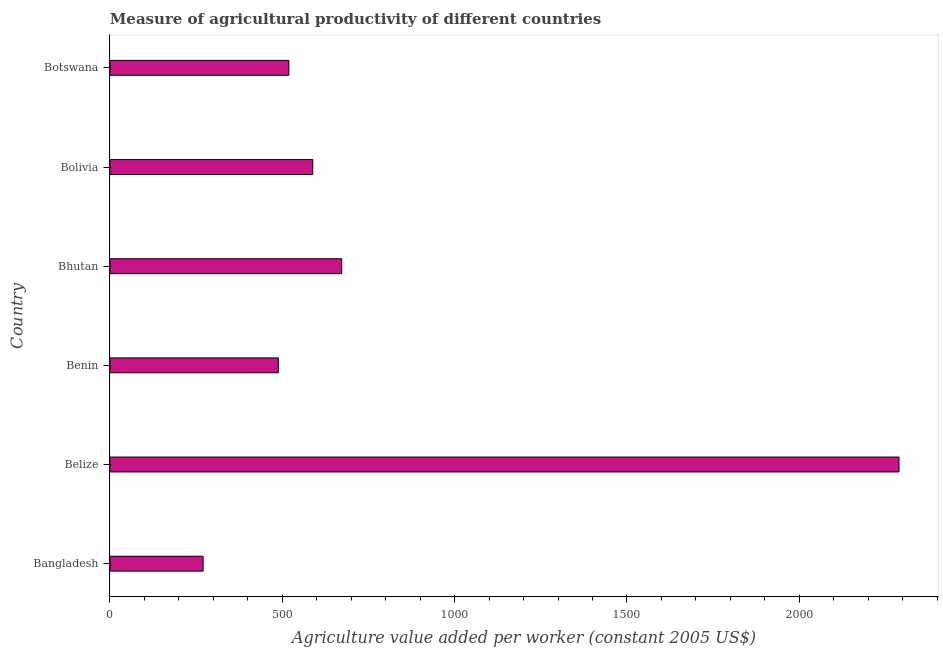What is the title of the graph?
Offer a very short reply. Measure of agricultural productivity of different countries. What is the label or title of the X-axis?
Keep it short and to the point. Agriculture value added per worker (constant 2005 US$). What is the label or title of the Y-axis?
Keep it short and to the point. Country. What is the agriculture value added per worker in Belize?
Give a very brief answer. 2289.18. Across all countries, what is the maximum agriculture value added per worker?
Offer a very short reply. 2289.18. Across all countries, what is the minimum agriculture value added per worker?
Ensure brevity in your answer.  270.45. In which country was the agriculture value added per worker maximum?
Make the answer very short. Belize. In which country was the agriculture value added per worker minimum?
Make the answer very short. Bangladesh. What is the sum of the agriculture value added per worker?
Provide a short and direct response. 4828.3. What is the difference between the agriculture value added per worker in Bolivia and Botswana?
Your answer should be very brief. 69.4. What is the average agriculture value added per worker per country?
Your response must be concise. 804.72. What is the median agriculture value added per worker?
Make the answer very short. 553.83. In how many countries, is the agriculture value added per worker greater than 1400 US$?
Your response must be concise. 1. What is the ratio of the agriculture value added per worker in Benin to that in Botswana?
Provide a short and direct response. 0.94. What is the difference between the highest and the second highest agriculture value added per worker?
Offer a very short reply. 1616.75. Is the sum of the agriculture value added per worker in Belize and Botswana greater than the maximum agriculture value added per worker across all countries?
Provide a short and direct response. Yes. What is the difference between the highest and the lowest agriculture value added per worker?
Your answer should be compact. 2018.73. How many bars are there?
Provide a short and direct response. 6. How many countries are there in the graph?
Give a very brief answer. 6. What is the difference between two consecutive major ticks on the X-axis?
Provide a short and direct response. 500. Are the values on the major ticks of X-axis written in scientific E-notation?
Provide a short and direct response. No. What is the Agriculture value added per worker (constant 2005 US$) of Bangladesh?
Keep it short and to the point. 270.45. What is the Agriculture value added per worker (constant 2005 US$) of Belize?
Offer a terse response. 2289.18. What is the Agriculture value added per worker (constant 2005 US$) of Benin?
Offer a very short reply. 488.58. What is the Agriculture value added per worker (constant 2005 US$) of Bhutan?
Your answer should be compact. 672.43. What is the Agriculture value added per worker (constant 2005 US$) of Bolivia?
Give a very brief answer. 588.54. What is the Agriculture value added per worker (constant 2005 US$) in Botswana?
Ensure brevity in your answer.  519.13. What is the difference between the Agriculture value added per worker (constant 2005 US$) in Bangladesh and Belize?
Your answer should be very brief. -2018.73. What is the difference between the Agriculture value added per worker (constant 2005 US$) in Bangladesh and Benin?
Offer a terse response. -218.12. What is the difference between the Agriculture value added per worker (constant 2005 US$) in Bangladesh and Bhutan?
Provide a succinct answer. -401.97. What is the difference between the Agriculture value added per worker (constant 2005 US$) in Bangladesh and Bolivia?
Keep it short and to the point. -318.08. What is the difference between the Agriculture value added per worker (constant 2005 US$) in Bangladesh and Botswana?
Your response must be concise. -248.68. What is the difference between the Agriculture value added per worker (constant 2005 US$) in Belize and Benin?
Provide a succinct answer. 1800.6. What is the difference between the Agriculture value added per worker (constant 2005 US$) in Belize and Bhutan?
Provide a succinct answer. 1616.75. What is the difference between the Agriculture value added per worker (constant 2005 US$) in Belize and Bolivia?
Give a very brief answer. 1700.64. What is the difference between the Agriculture value added per worker (constant 2005 US$) in Belize and Botswana?
Your response must be concise. 1770.04. What is the difference between the Agriculture value added per worker (constant 2005 US$) in Benin and Bhutan?
Ensure brevity in your answer.  -183.85. What is the difference between the Agriculture value added per worker (constant 2005 US$) in Benin and Bolivia?
Keep it short and to the point. -99.96. What is the difference between the Agriculture value added per worker (constant 2005 US$) in Benin and Botswana?
Offer a terse response. -30.56. What is the difference between the Agriculture value added per worker (constant 2005 US$) in Bhutan and Bolivia?
Offer a terse response. 83.89. What is the difference between the Agriculture value added per worker (constant 2005 US$) in Bhutan and Botswana?
Provide a short and direct response. 153.29. What is the difference between the Agriculture value added per worker (constant 2005 US$) in Bolivia and Botswana?
Offer a very short reply. 69.4. What is the ratio of the Agriculture value added per worker (constant 2005 US$) in Bangladesh to that in Belize?
Offer a terse response. 0.12. What is the ratio of the Agriculture value added per worker (constant 2005 US$) in Bangladesh to that in Benin?
Your response must be concise. 0.55. What is the ratio of the Agriculture value added per worker (constant 2005 US$) in Bangladesh to that in Bhutan?
Ensure brevity in your answer.  0.4. What is the ratio of the Agriculture value added per worker (constant 2005 US$) in Bangladesh to that in Bolivia?
Give a very brief answer. 0.46. What is the ratio of the Agriculture value added per worker (constant 2005 US$) in Bangladesh to that in Botswana?
Your response must be concise. 0.52. What is the ratio of the Agriculture value added per worker (constant 2005 US$) in Belize to that in Benin?
Give a very brief answer. 4.68. What is the ratio of the Agriculture value added per worker (constant 2005 US$) in Belize to that in Bhutan?
Your response must be concise. 3.4. What is the ratio of the Agriculture value added per worker (constant 2005 US$) in Belize to that in Bolivia?
Your answer should be very brief. 3.89. What is the ratio of the Agriculture value added per worker (constant 2005 US$) in Belize to that in Botswana?
Give a very brief answer. 4.41. What is the ratio of the Agriculture value added per worker (constant 2005 US$) in Benin to that in Bhutan?
Provide a succinct answer. 0.73. What is the ratio of the Agriculture value added per worker (constant 2005 US$) in Benin to that in Bolivia?
Ensure brevity in your answer.  0.83. What is the ratio of the Agriculture value added per worker (constant 2005 US$) in Benin to that in Botswana?
Offer a very short reply. 0.94. What is the ratio of the Agriculture value added per worker (constant 2005 US$) in Bhutan to that in Bolivia?
Offer a terse response. 1.14. What is the ratio of the Agriculture value added per worker (constant 2005 US$) in Bhutan to that in Botswana?
Offer a very short reply. 1.29. What is the ratio of the Agriculture value added per worker (constant 2005 US$) in Bolivia to that in Botswana?
Keep it short and to the point. 1.13. 